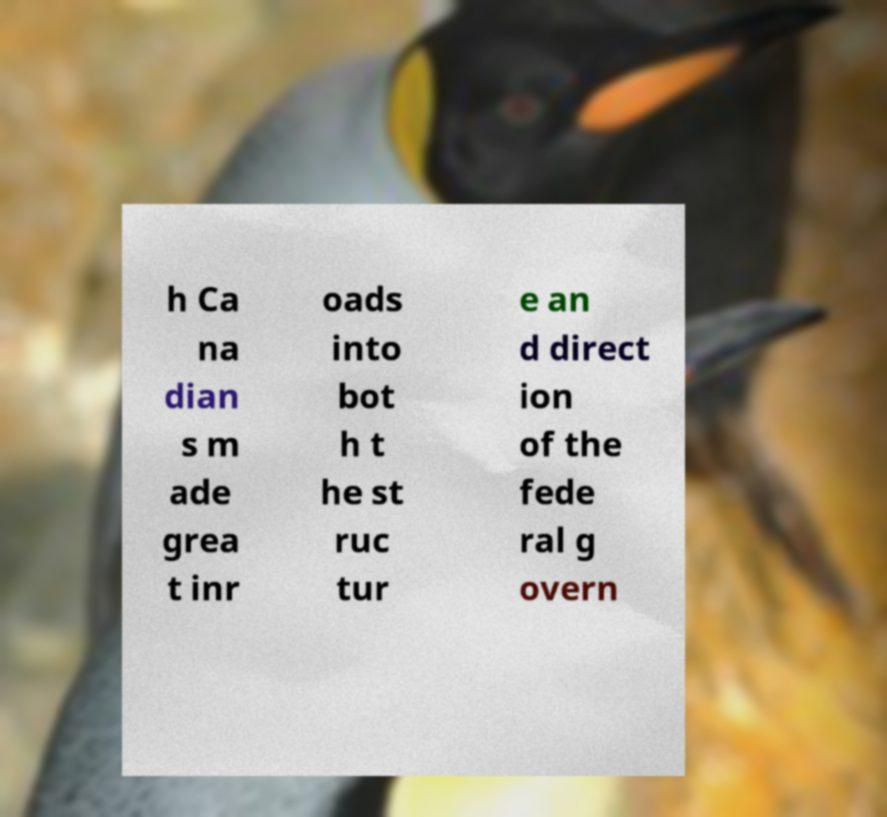There's text embedded in this image that I need extracted. Can you transcribe it verbatim? h Ca na dian s m ade grea t inr oads into bot h t he st ruc tur e an d direct ion of the fede ral g overn 